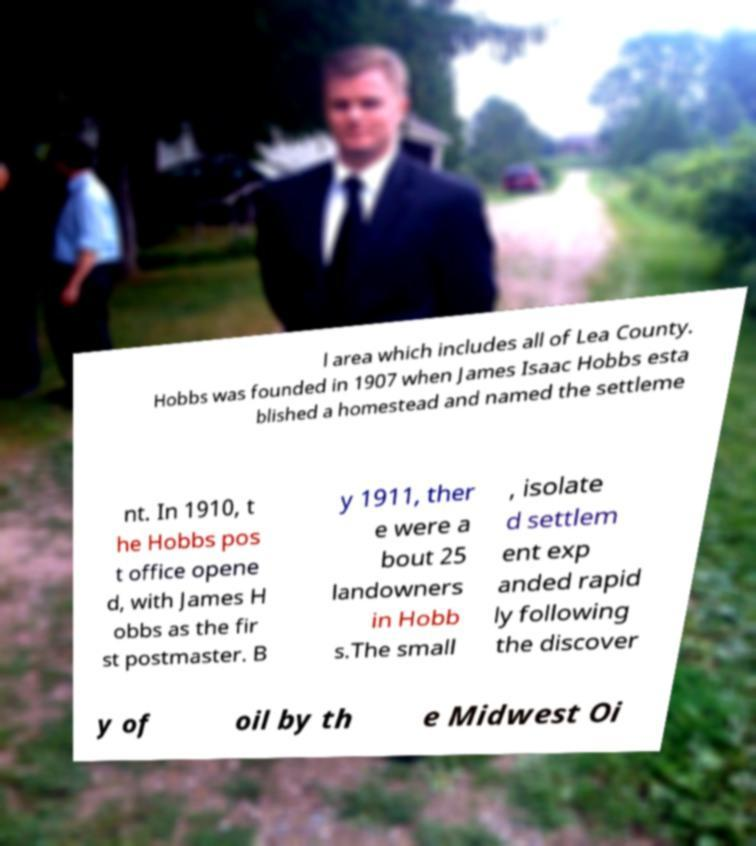Can you accurately transcribe the text from the provided image for me? l area which includes all of Lea County. Hobbs was founded in 1907 when James Isaac Hobbs esta blished a homestead and named the settleme nt. In 1910, t he Hobbs pos t office opene d, with James H obbs as the fir st postmaster. B y 1911, ther e were a bout 25 landowners in Hobb s.The small , isolate d settlem ent exp anded rapid ly following the discover y of oil by th e Midwest Oi 